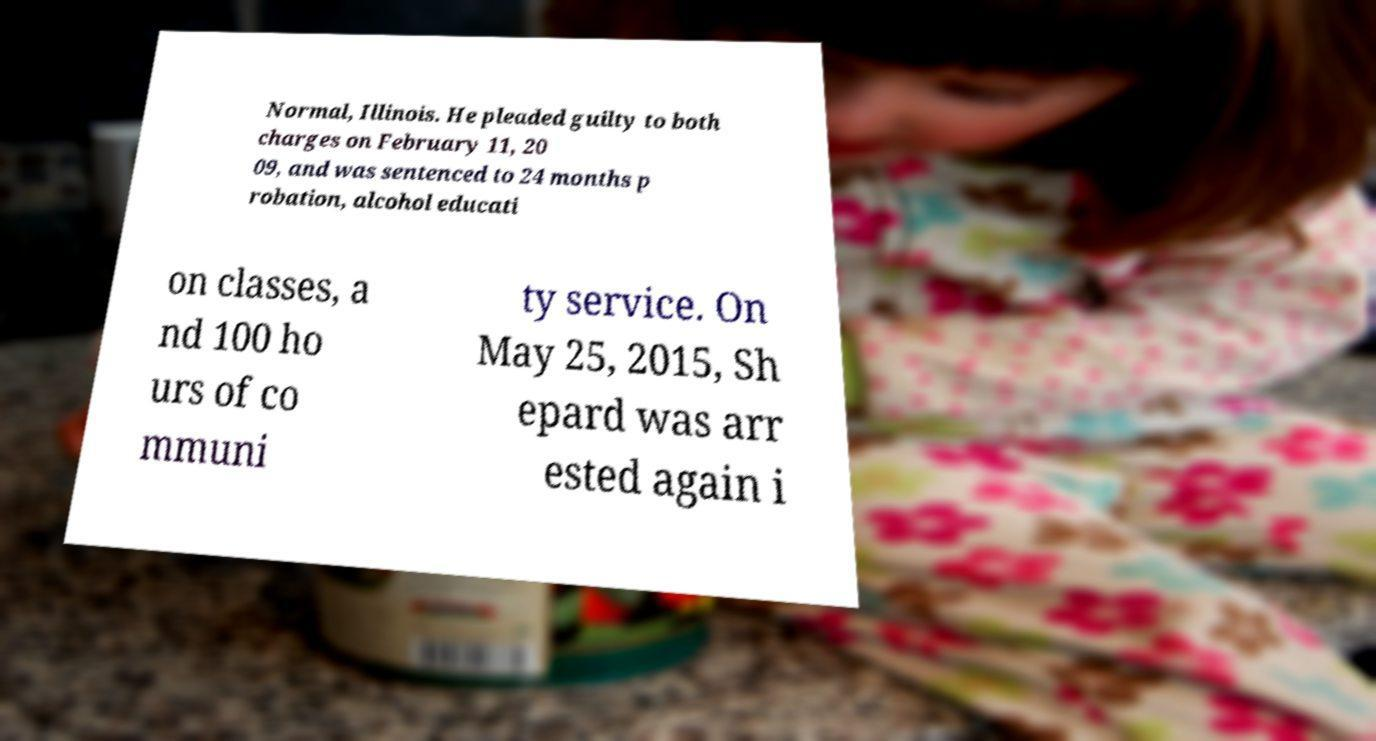Can you accurately transcribe the text from the provided image for me? Normal, Illinois. He pleaded guilty to both charges on February 11, 20 09, and was sentenced to 24 months p robation, alcohol educati on classes, a nd 100 ho urs of co mmuni ty service. On May 25, 2015, Sh epard was arr ested again i 